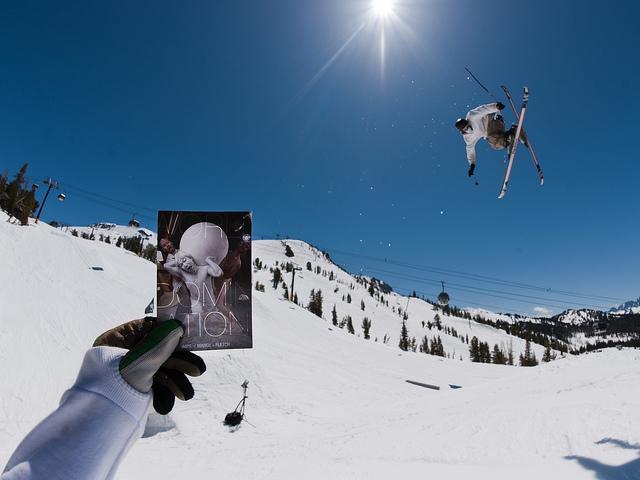How many people are wearing green?
Give a very brief answer. 0. How many people are there?
Give a very brief answer. 2. 